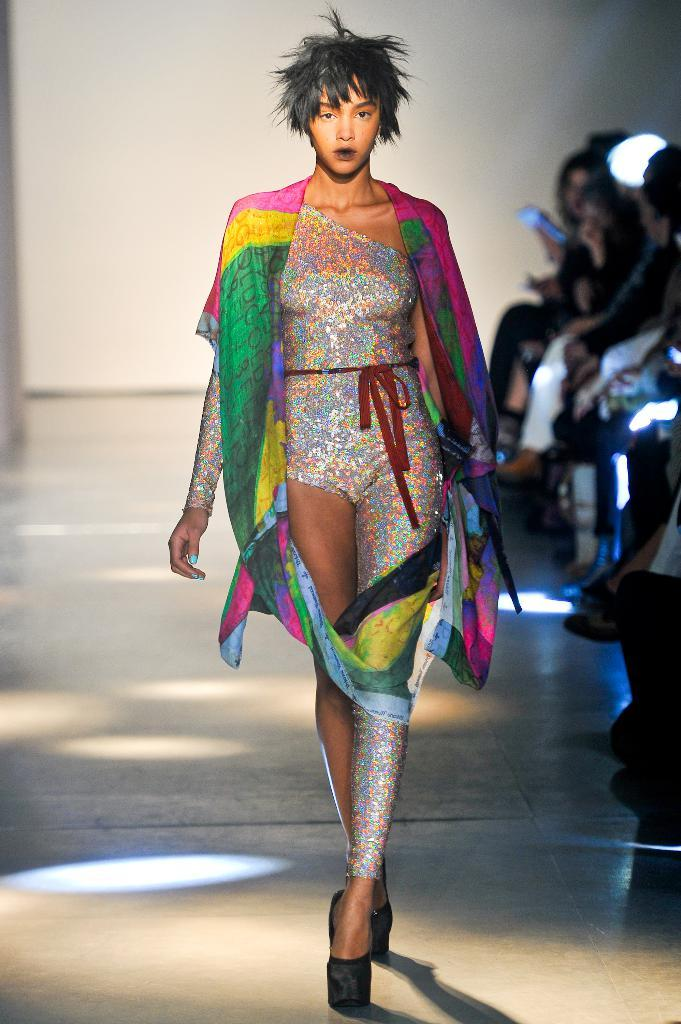Who is the main subject in the image? There is a woman in the image. What is the woman doing in the image? The woman is walking on the floor. Can you describe the background of the image? The background of the image is blurry. Are there any other people visible in the image? Yes, there are people visible in the background of the image. Where is the basin located in the image? There is no basin present in the image. What type of fowl can be seen in the image? There is no fowl present in the image. 